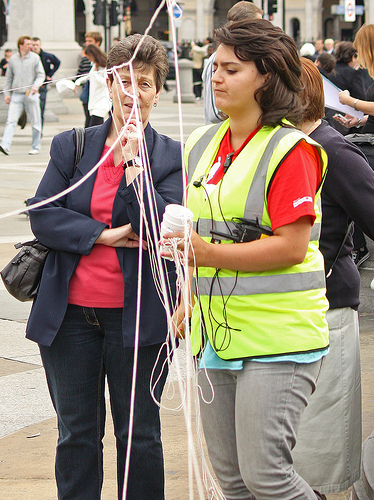<image>
Is there a woman next to the woman? Yes. The woman is positioned adjacent to the woman, located nearby in the same general area. Where is the man in relation to the woman? Is it next to the woman? No. The man is not positioned next to the woman. They are located in different areas of the scene. 